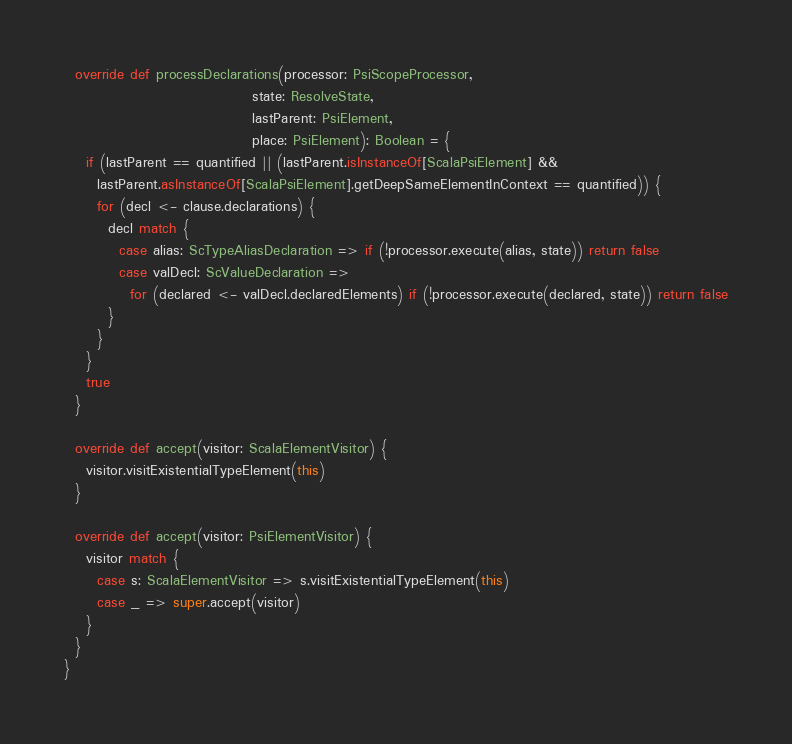<code> <loc_0><loc_0><loc_500><loc_500><_Scala_>  override def processDeclarations(processor: PsiScopeProcessor,
                                  state: ResolveState,
                                  lastParent: PsiElement,
                                  place: PsiElement): Boolean = {
    if (lastParent == quantified || (lastParent.isInstanceOf[ScalaPsiElement] &&
      lastParent.asInstanceOf[ScalaPsiElement].getDeepSameElementInContext == quantified)) {
      for (decl <- clause.declarations) {
        decl match {
          case alias: ScTypeAliasDeclaration => if (!processor.execute(alias, state)) return false
          case valDecl: ScValueDeclaration =>
            for (declared <- valDecl.declaredElements) if (!processor.execute(declared, state)) return false
        }
      }
    }
    true
  }

  override def accept(visitor: ScalaElementVisitor) {
    visitor.visitExistentialTypeElement(this)
  }

  override def accept(visitor: PsiElementVisitor) {
    visitor match {
      case s: ScalaElementVisitor => s.visitExistentialTypeElement(this)
      case _ => super.accept(visitor)
    }
  }
}</code> 